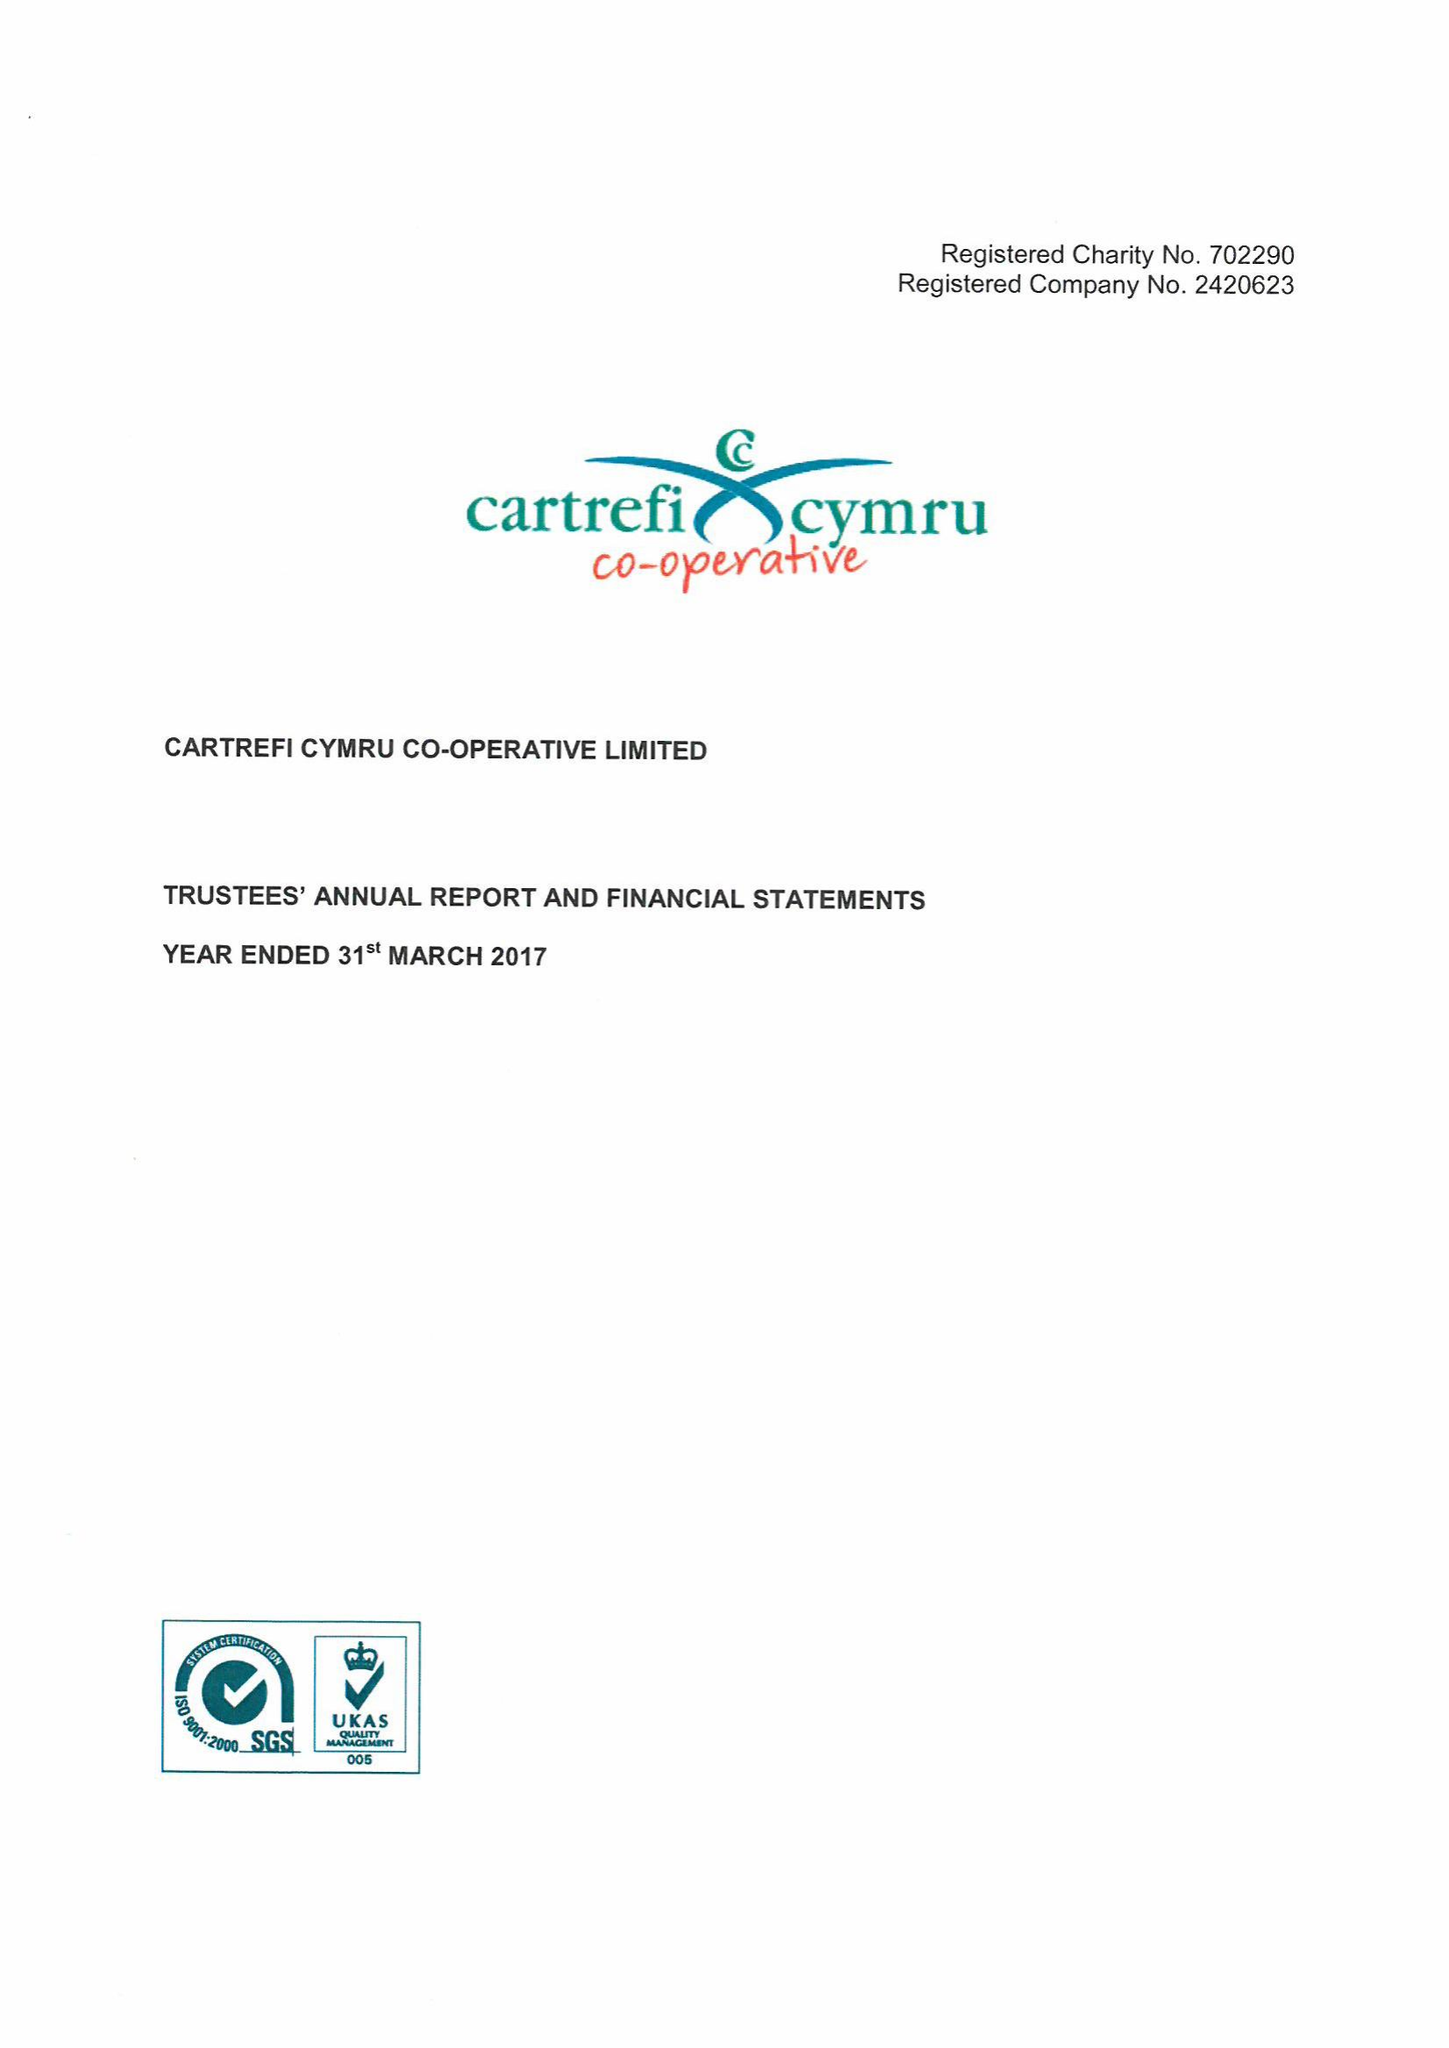What is the value for the charity_number?
Answer the question using a single word or phrase. 702290 